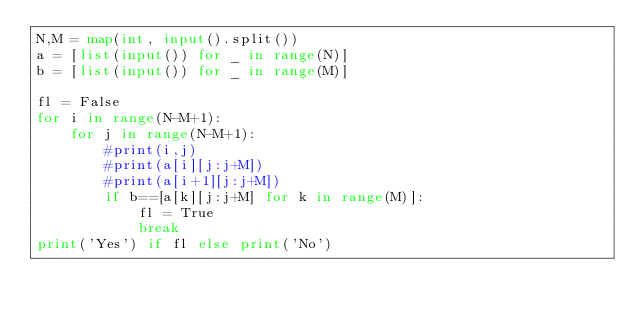Convert code to text. <code><loc_0><loc_0><loc_500><loc_500><_Python_>N,M = map(int, input().split())
a = [list(input()) for _ in range(N)]
b = [list(input()) for _ in range(M)]

fl = False
for i in range(N-M+1):
    for j in range(N-M+1):
        #print(i,j)
        #print(a[i][j:j+M])
        #print(a[i+1][j:j+M])
        if b==[a[k][j:j+M] for k in range(M)]:
            fl = True
            break
print('Yes') if fl else print('No')</code> 